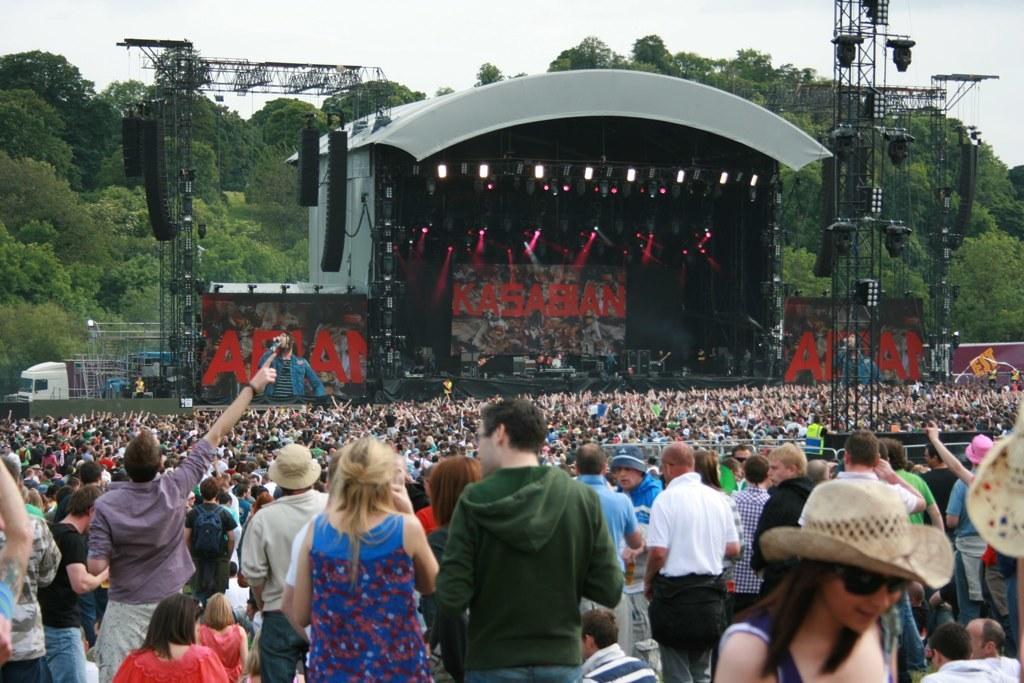In one or two sentences, can you explain what this image depicts? In this image I can see number of persons standing and I can see some of them are wearing hats. In the background I can see the stage, few persons on the stage, two huge screens, few towers which are made of metal rods, few lights, few trees and the sky. 